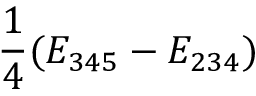Convert formula to latex. <formula><loc_0><loc_0><loc_500><loc_500>\frac { 1 } { 4 } ( E _ { 3 4 5 } - E _ { 2 3 4 } )</formula> 